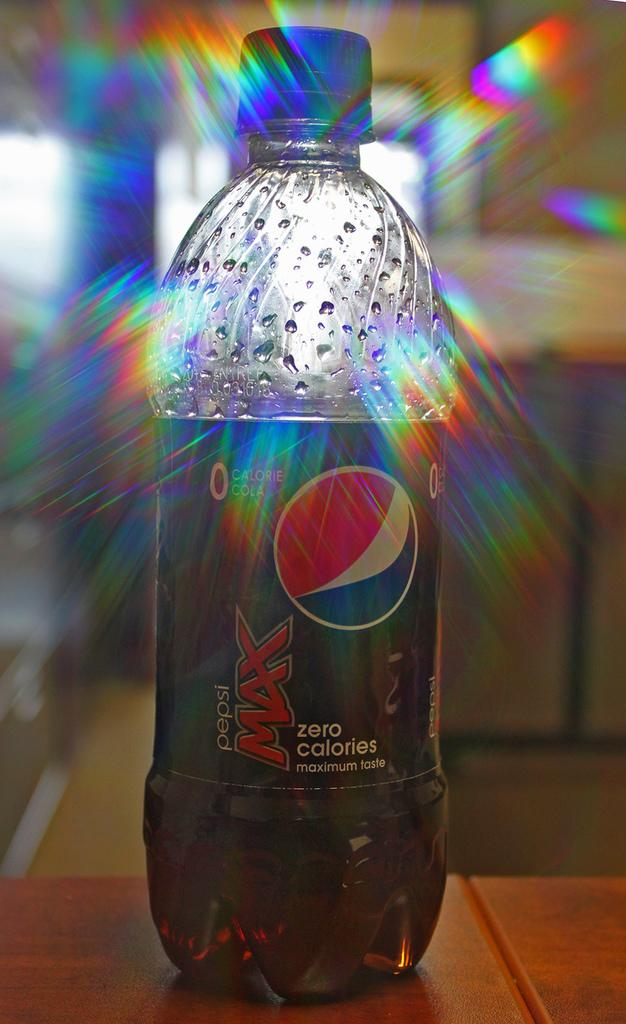Provide a one-sentence caption for the provided image. A bottle of Pepsi Max is not full and has a blue cap. 